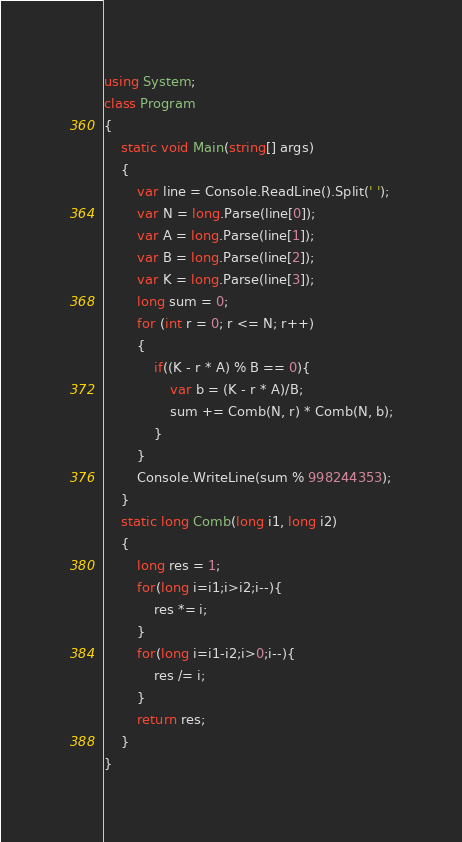<code> <loc_0><loc_0><loc_500><loc_500><_C#_>using System;
class Program
{
    static void Main(string[] args)
    {
        var line = Console.ReadLine().Split(' ');
        var N = long.Parse(line[0]);
        var A = long.Parse(line[1]);
        var B = long.Parse(line[2]);
        var K = long.Parse(line[3]);
        long sum = 0;
        for (int r = 0; r <= N; r++)
        {
            if((K - r * A) % B == 0){
                var b = (K - r * A)/B;
                sum += Comb(N, r) * Comb(N, b);
            }
        }
        Console.WriteLine(sum % 998244353);
    }
    static long Comb(long i1, long i2)
    {
        long res = 1;
        for(long i=i1;i>i2;i--){
            res *= i;
        }
        for(long i=i1-i2;i>0;i--){
            res /= i;
        }
        return res;
    }
}
</code> 